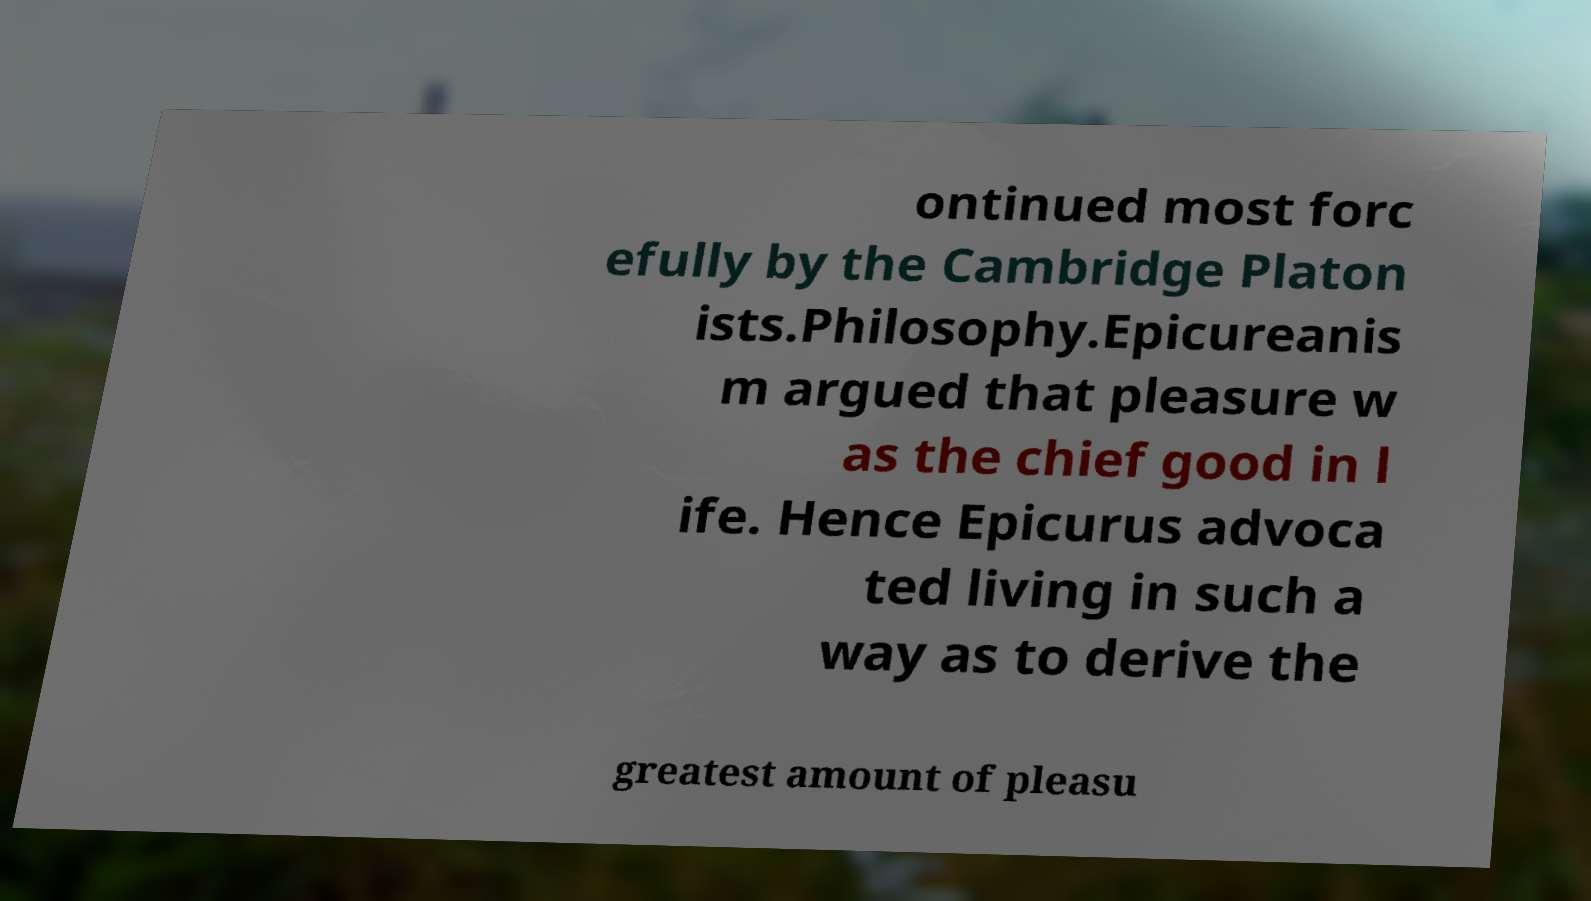Can you read and provide the text displayed in the image?This photo seems to have some interesting text. Can you extract and type it out for me? ontinued most forc efully by the Cambridge Platon ists.Philosophy.Epicureanis m argued that pleasure w as the chief good in l ife. Hence Epicurus advoca ted living in such a way as to derive the greatest amount of pleasu 